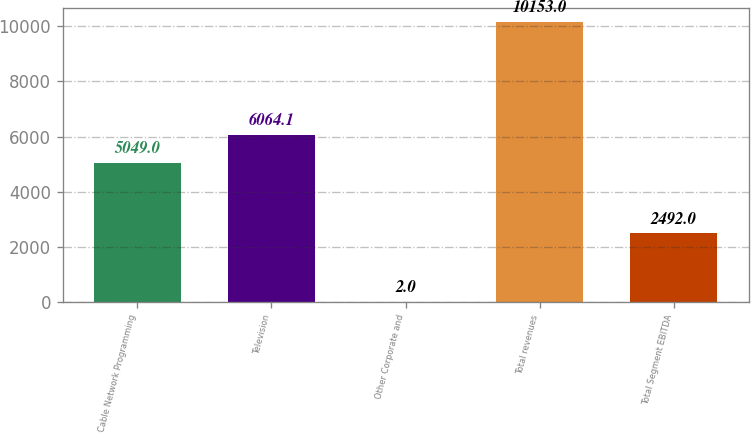Convert chart to OTSL. <chart><loc_0><loc_0><loc_500><loc_500><bar_chart><fcel>Cable Network Programming<fcel>Television<fcel>Other Corporate and<fcel>Total revenues<fcel>Total Segment EBITDA<nl><fcel>5049<fcel>6064.1<fcel>2<fcel>10153<fcel>2492<nl></chart> 